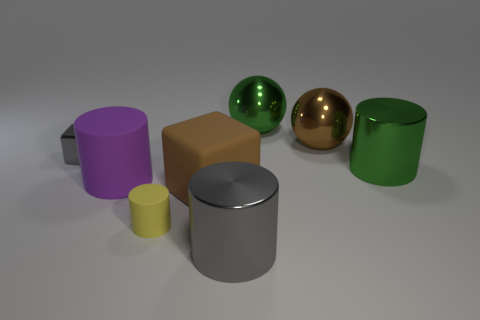What is the overall mood conveyed by the image, and what elements contribute to it? The image conveys a calm and orderly mood, which is achieved by the soft lighting, the neutral background, and the simple, clean arrangement of geometric shapes. 